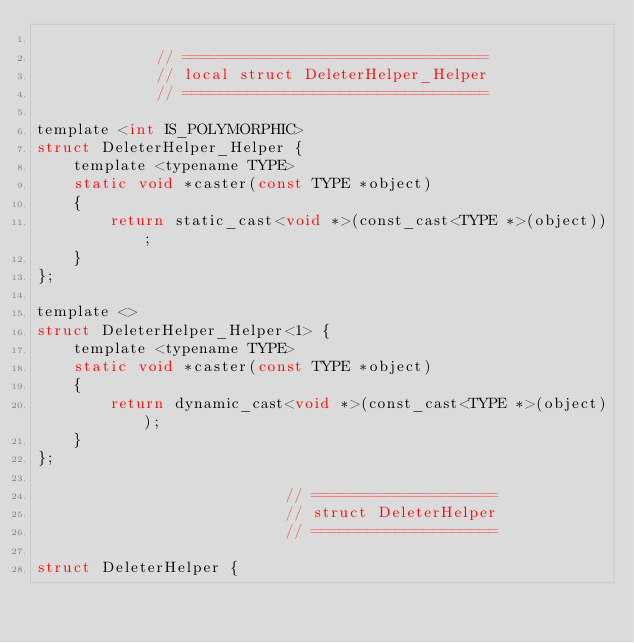Convert code to text. <code><loc_0><loc_0><loc_500><loc_500><_C_>
             // =================================
             // local struct DeleterHelper_Helper
             // =================================

template <int IS_POLYMORPHIC>
struct DeleterHelper_Helper {
    template <typename TYPE>
    static void *caster(const TYPE *object)
    {
        return static_cast<void *>(const_cast<TYPE *>(object));
    }
};

template <>
struct DeleterHelper_Helper<1> {
    template <typename TYPE>
    static void *caster(const TYPE *object)
    {
        return dynamic_cast<void *>(const_cast<TYPE *>(object));
    }
};

                           // ====================
                           // struct DeleterHelper
                           // ====================

struct DeleterHelper {</code> 